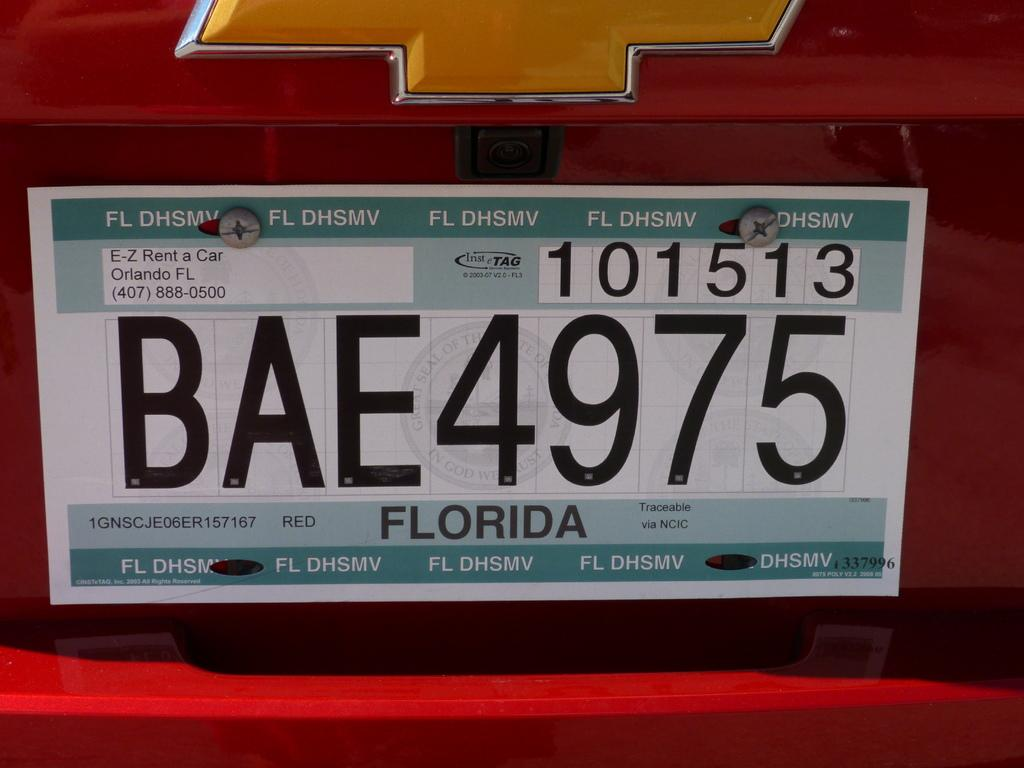Provide a one-sentence caption for the provided image. a FLORIDA license plate on a red car with BAE4975 on it. 